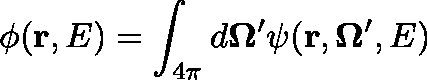Convert formula to latex. <formula><loc_0><loc_0><loc_500><loc_500>\phi ( r , E ) = \int _ { 4 \pi } d \Omega ^ { \prime } \psi ( r , \Omega ^ { \prime } , E )</formula> 